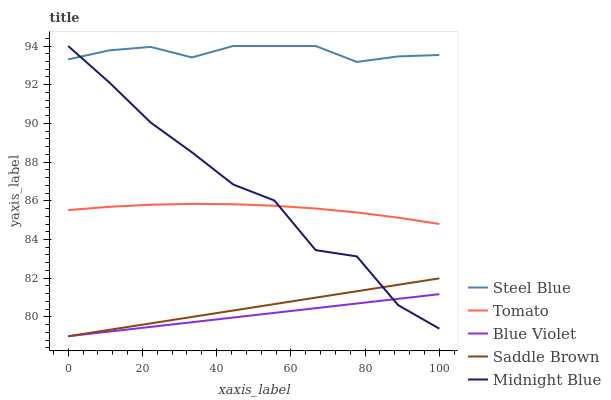Does Blue Violet have the minimum area under the curve?
Answer yes or no. Yes. Does Steel Blue have the maximum area under the curve?
Answer yes or no. Yes. Does Midnight Blue have the minimum area under the curve?
Answer yes or no. No. Does Midnight Blue have the maximum area under the curve?
Answer yes or no. No. Is Saddle Brown the smoothest?
Answer yes or no. Yes. Is Midnight Blue the roughest?
Answer yes or no. Yes. Is Steel Blue the smoothest?
Answer yes or no. No. Is Steel Blue the roughest?
Answer yes or no. No. Does Blue Violet have the lowest value?
Answer yes or no. Yes. Does Midnight Blue have the lowest value?
Answer yes or no. No. Does Steel Blue have the highest value?
Answer yes or no. Yes. Does Blue Violet have the highest value?
Answer yes or no. No. Is Saddle Brown less than Steel Blue?
Answer yes or no. Yes. Is Steel Blue greater than Saddle Brown?
Answer yes or no. Yes. Does Midnight Blue intersect Saddle Brown?
Answer yes or no. Yes. Is Midnight Blue less than Saddle Brown?
Answer yes or no. No. Is Midnight Blue greater than Saddle Brown?
Answer yes or no. No. Does Saddle Brown intersect Steel Blue?
Answer yes or no. No. 